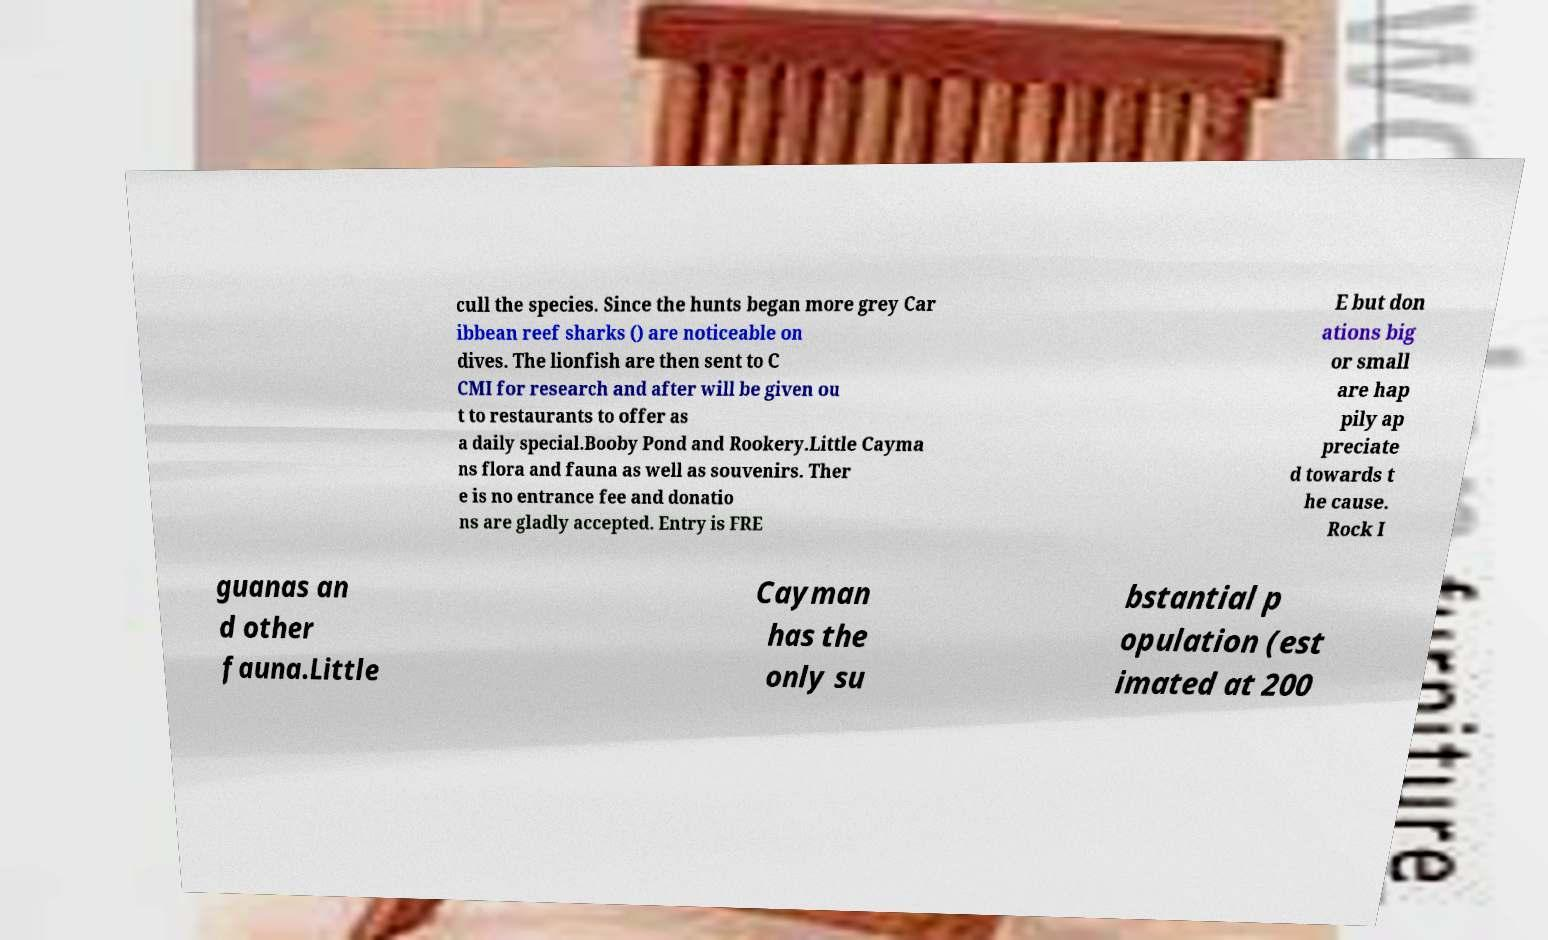Could you assist in decoding the text presented in this image and type it out clearly? cull the species. Since the hunts began more grey Car ibbean reef sharks () are noticeable on dives. The lionfish are then sent to C CMI for research and after will be given ou t to restaurants to offer as a daily special.Booby Pond and Rookery.Little Cayma ns flora and fauna as well as souvenirs. Ther e is no entrance fee and donatio ns are gladly accepted. Entry is FRE E but don ations big or small are hap pily ap preciate d towards t he cause. Rock I guanas an d other fauna.Little Cayman has the only su bstantial p opulation (est imated at 200 